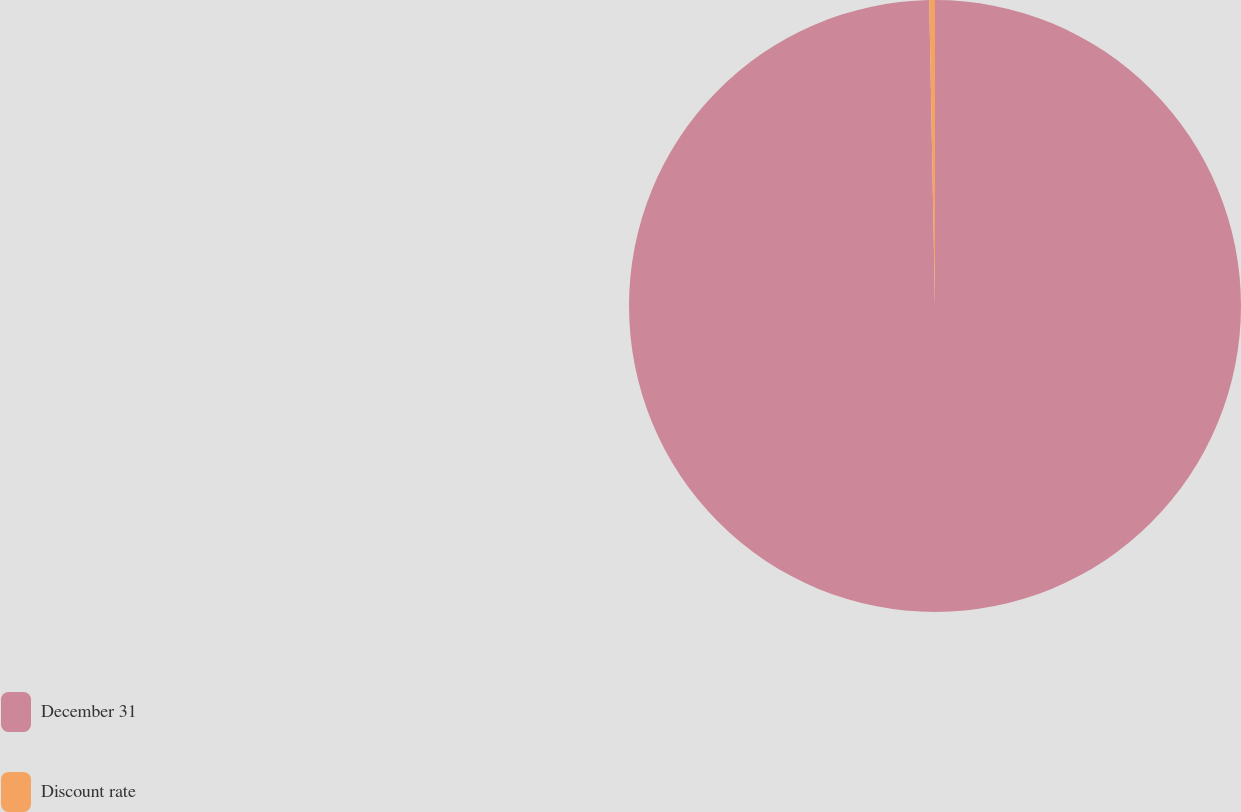Convert chart. <chart><loc_0><loc_0><loc_500><loc_500><pie_chart><fcel>December 31<fcel>Discount rate<nl><fcel>99.7%<fcel>0.3%<nl></chart> 